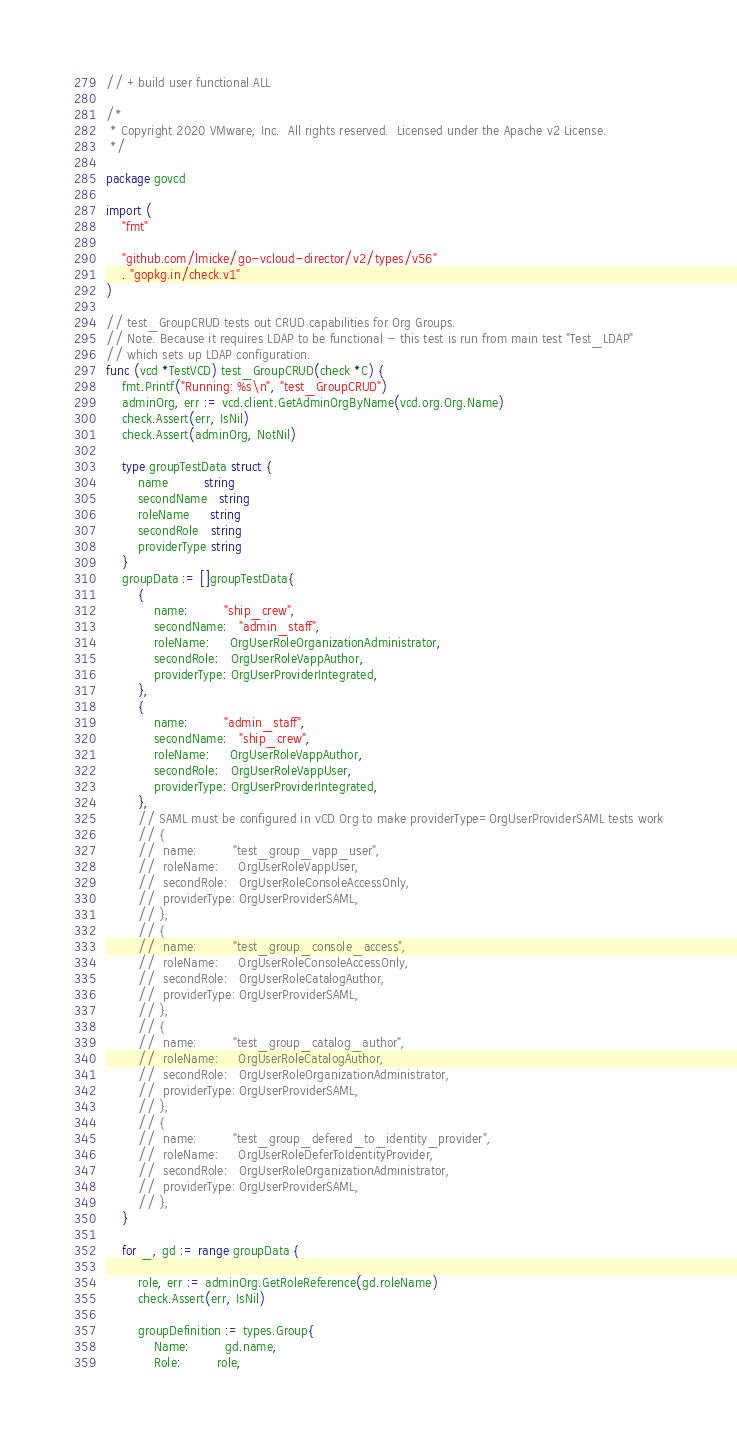Convert code to text. <code><loc_0><loc_0><loc_500><loc_500><_Go_>// +build user functional ALL

/*
 * Copyright 2020 VMware, Inc.  All rights reserved.  Licensed under the Apache v2 License.
 */

package govcd

import (
	"fmt"

	"github.com/lmicke/go-vcloud-director/v2/types/v56"
	. "gopkg.in/check.v1"
)

// test_GroupCRUD tests out CRUD capabilities for Org Groups.
// Note. Because it requires LDAP to be functional - this test is run from main test "Test_LDAP"
// which sets up LDAP configuration.
func (vcd *TestVCD) test_GroupCRUD(check *C) {
	fmt.Printf("Running: %s\n", "test_GroupCRUD")
	adminOrg, err := vcd.client.GetAdminOrgByName(vcd.org.Org.Name)
	check.Assert(err, IsNil)
	check.Assert(adminOrg, NotNil)

	type groupTestData struct {
		name         string
		secondName   string
		roleName     string
		secondRole   string
		providerType string
	}
	groupData := []groupTestData{
		{
			name:         "ship_crew",
			secondName:   "admin_staff",
			roleName:     OrgUserRoleOrganizationAdministrator,
			secondRole:   OrgUserRoleVappAuthor,
			providerType: OrgUserProviderIntegrated,
		},
		{
			name:         "admin_staff",
			secondName:   "ship_crew",
			roleName:     OrgUserRoleVappAuthor,
			secondRole:   OrgUserRoleVappUser,
			providerType: OrgUserProviderIntegrated,
		},
		// SAML must be configured in vCD Org to make providerType=OrgUserProviderSAML tests work
		// {
		// 	name:         "test_group_vapp_user",
		// 	roleName:     OrgUserRoleVappUser,
		// 	secondRole:   OrgUserRoleConsoleAccessOnly,
		// 	providerType: OrgUserProviderSAML,
		// },
		// {
		// 	name:         "test_group_console_access",
		// 	roleName:     OrgUserRoleConsoleAccessOnly,
		// 	secondRole:   OrgUserRoleCatalogAuthor,
		// 	providerType: OrgUserProviderSAML,
		// },
		// {
		// 	name:         "test_group_catalog_author",
		// 	roleName:     OrgUserRoleCatalogAuthor,
		// 	secondRole:   OrgUserRoleOrganizationAdministrator,
		// 	providerType: OrgUserProviderSAML,
		// },
		// {
		// 	name:         "test_group_defered_to_identity_provider",
		// 	roleName:     OrgUserRoleDeferToIdentityProvider,
		// 	secondRole:   OrgUserRoleOrganizationAdministrator,
		// 	providerType: OrgUserProviderSAML,
		// },
	}

	for _, gd := range groupData {

		role, err := adminOrg.GetRoleReference(gd.roleName)
		check.Assert(err, IsNil)

		groupDefinition := types.Group{
			Name:         gd.name,
			Role:         role,</code> 